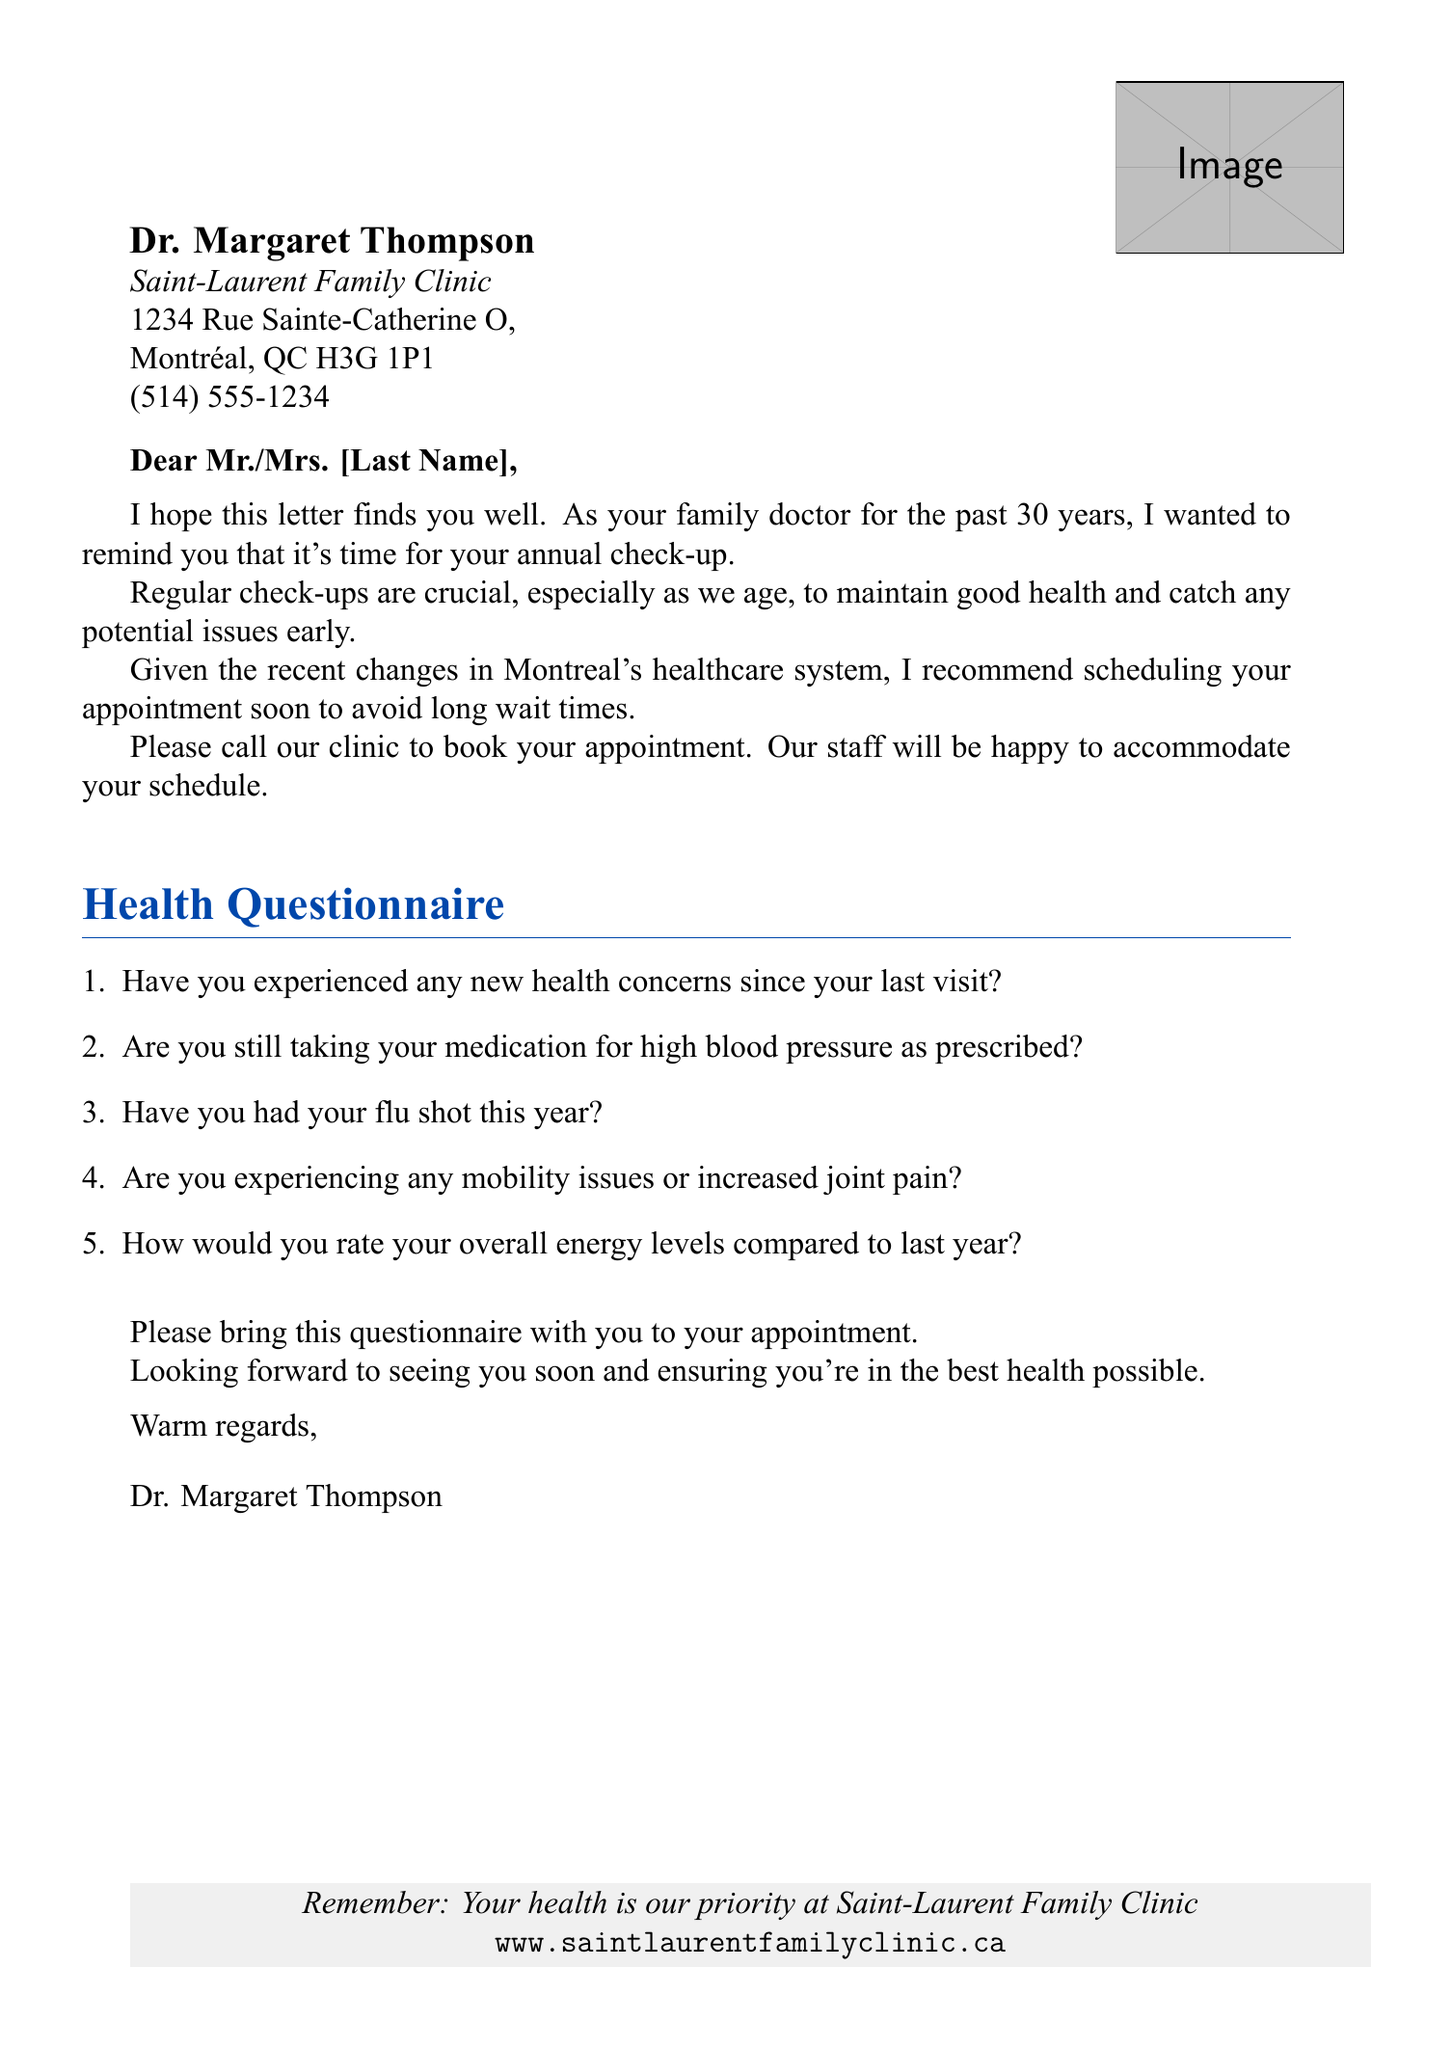What is the name of the doctor? The document states the doctor's name at the top, which is Dr. Margaret Thompson.
Answer: Dr. Margaret Thompson What is the address of the clinic? The address of the clinic is included in the letterhead section, which shows where it is located.
Answer: 1234 Rue Sainte-Catherine O, Montréal, QC H3G 1P1 What is the phone number of the clinic? The phone number is provided in the document and can be found in the letterhead section.
Answer: (514) 555-1234 How many years has Dr. Thompson been your family doctor? The letter mentions that Dr. Thompson has been the family doctor for the past 30 years.
Answer: 30 years What is one reason given for scheduling the appointment soon? The document discusses wanting to avoid long wait times as a reason for scheduling the appointment soon.
Answer: Avoid long wait times What is the first question in the health questionnaire? The first item listed in the health questionnaire section asks about new health concerns since the last visit.
Answer: Have you experienced any new health concerns since your last visit? What should you bring to your appointment? The letter specifies that the questionnaire should be brought to the appointment.
Answer: This questionnaire What does the closing remark emphasize? The closing remark mentions looking forward to seeing the patient and ensuring good health, emphasizing care and attention.
Answer: Ensuring you're in the best health possible What is the website for the clinic? The footer of the document provides the website for more information about the clinic.
Answer: www.saintlaurentfamilyclinic.ca 